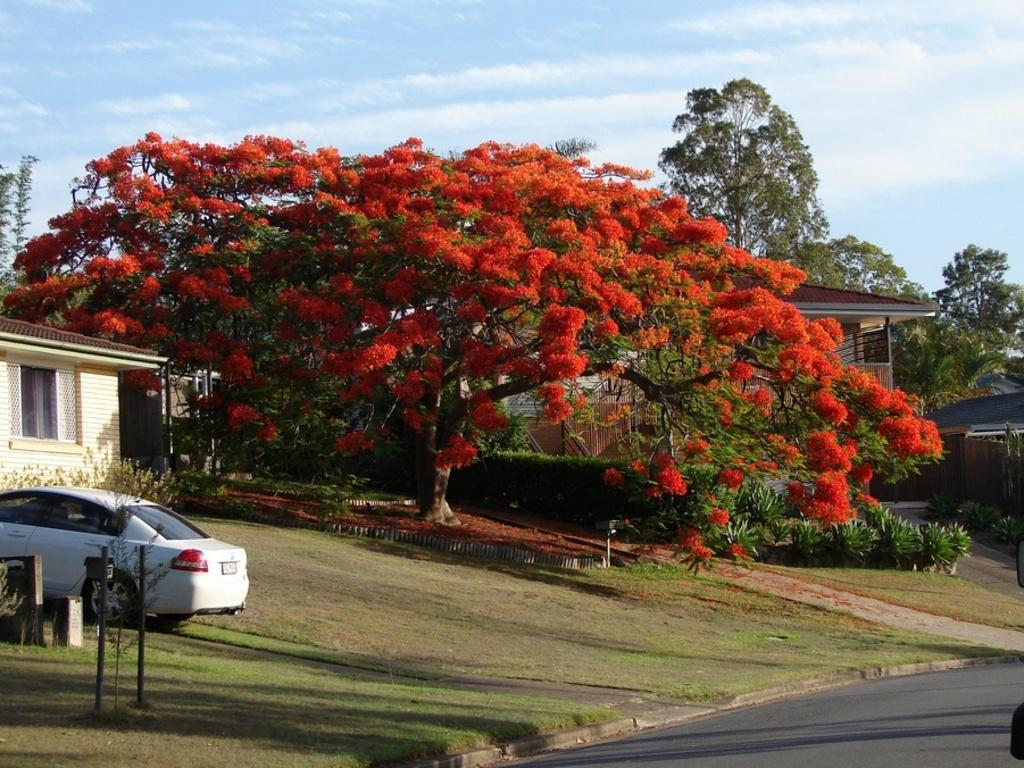What is the main feature of the image? There is a road in the image. What can be seen on the left side of the image? There is a car and a building on the left side of the image. What is located in the center of the image? There is a tree in the center of the image. What is visible in the sky at the top of the image? There are clouds visible in the sky at the top of the image. What type of protest is happening in the image? There is no protest present in the image; it features a road, a car, a building, a tree, and clouds. What muscle is being exercised by the tree in the image? Trees do not have muscles, so this question is not applicable to the image. 